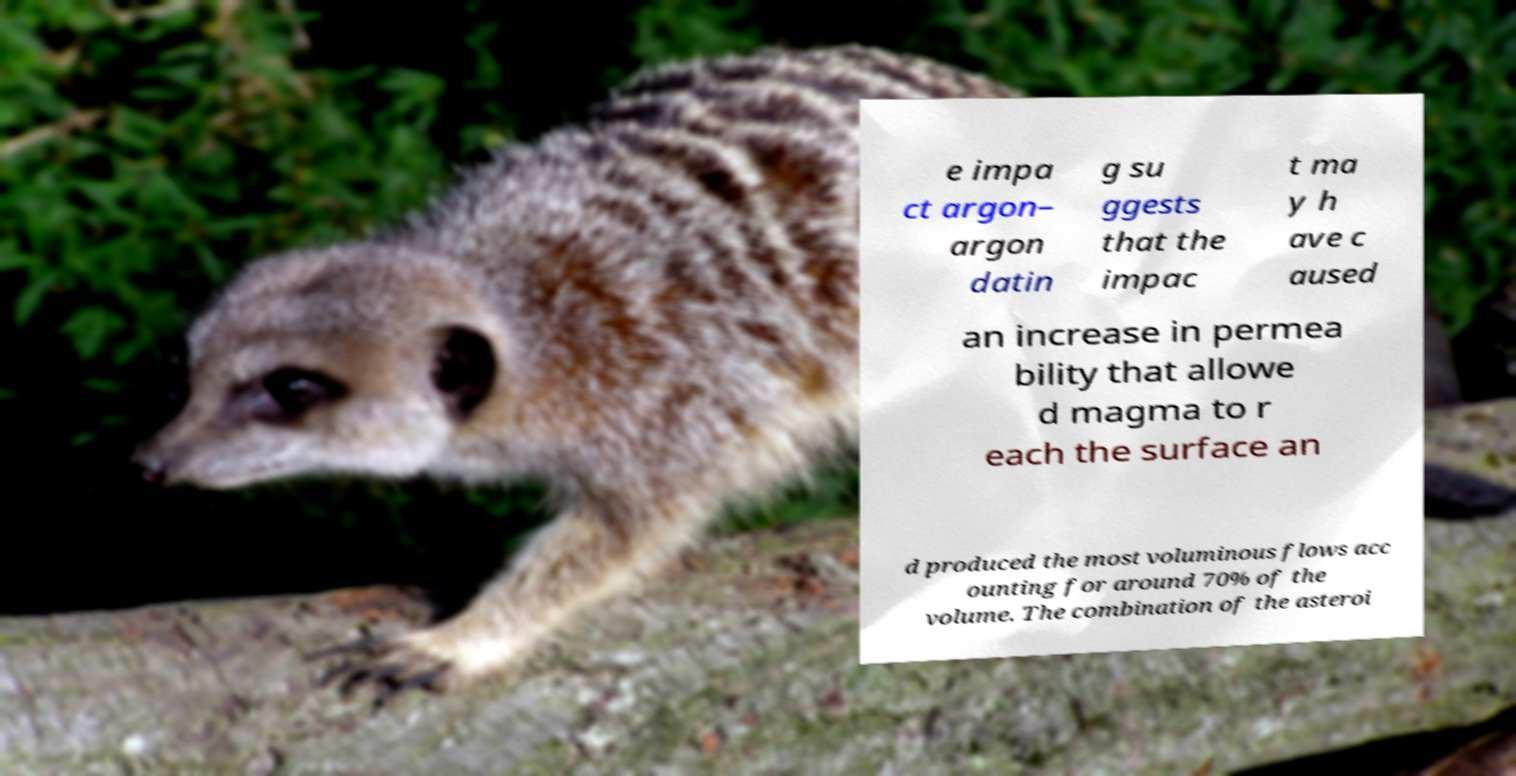Can you read and provide the text displayed in the image?This photo seems to have some interesting text. Can you extract and type it out for me? e impa ct argon– argon datin g su ggests that the impac t ma y h ave c aused an increase in permea bility that allowe d magma to r each the surface an d produced the most voluminous flows acc ounting for around 70% of the volume. The combination of the asteroi 